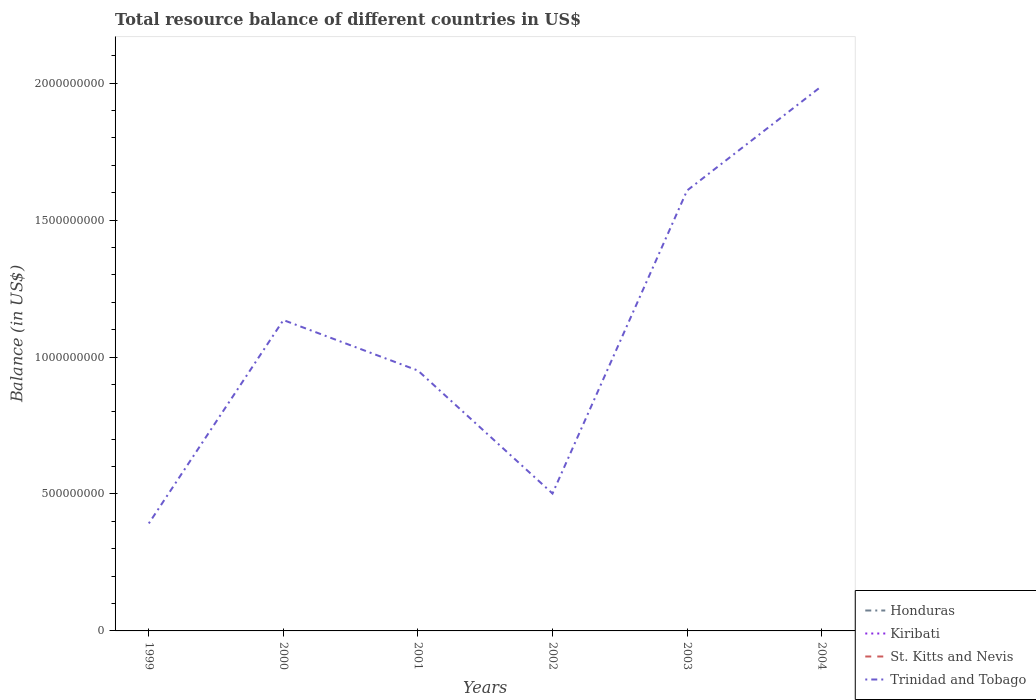How many different coloured lines are there?
Offer a terse response. 1. What is the total total resource balance in Trinidad and Tobago in the graph?
Ensure brevity in your answer.  -4.73e+08. Is the total resource balance in Kiribati strictly greater than the total resource balance in Trinidad and Tobago over the years?
Give a very brief answer. Yes. How many lines are there?
Provide a short and direct response. 1. How many years are there in the graph?
Make the answer very short. 6. How many legend labels are there?
Offer a very short reply. 4. How are the legend labels stacked?
Your answer should be very brief. Vertical. What is the title of the graph?
Provide a short and direct response. Total resource balance of different countries in US$. Does "Korea (Republic)" appear as one of the legend labels in the graph?
Offer a very short reply. No. What is the label or title of the X-axis?
Offer a very short reply. Years. What is the label or title of the Y-axis?
Your response must be concise. Balance (in US$). What is the Balance (in US$) in Honduras in 1999?
Keep it short and to the point. 0. What is the Balance (in US$) of Kiribati in 1999?
Your response must be concise. 0. What is the Balance (in US$) in Trinidad and Tobago in 1999?
Keep it short and to the point. 3.92e+08. What is the Balance (in US$) in Honduras in 2000?
Offer a terse response. 0. What is the Balance (in US$) of Kiribati in 2000?
Your response must be concise. 0. What is the Balance (in US$) of Trinidad and Tobago in 2000?
Provide a succinct answer. 1.13e+09. What is the Balance (in US$) in Honduras in 2001?
Offer a very short reply. 0. What is the Balance (in US$) of Kiribati in 2001?
Give a very brief answer. 0. What is the Balance (in US$) in Trinidad and Tobago in 2001?
Ensure brevity in your answer.  9.51e+08. What is the Balance (in US$) of Honduras in 2002?
Provide a succinct answer. 0. What is the Balance (in US$) of St. Kitts and Nevis in 2002?
Provide a short and direct response. 0. What is the Balance (in US$) in Trinidad and Tobago in 2002?
Ensure brevity in your answer.  5.02e+08. What is the Balance (in US$) of Honduras in 2003?
Make the answer very short. 0. What is the Balance (in US$) in Kiribati in 2003?
Offer a terse response. 0. What is the Balance (in US$) of Trinidad and Tobago in 2003?
Ensure brevity in your answer.  1.61e+09. What is the Balance (in US$) in Kiribati in 2004?
Provide a short and direct response. 0. What is the Balance (in US$) in St. Kitts and Nevis in 2004?
Make the answer very short. 0. What is the Balance (in US$) in Trinidad and Tobago in 2004?
Keep it short and to the point. 1.99e+09. Across all years, what is the maximum Balance (in US$) in Trinidad and Tobago?
Provide a short and direct response. 1.99e+09. Across all years, what is the minimum Balance (in US$) in Trinidad and Tobago?
Offer a very short reply. 3.92e+08. What is the total Balance (in US$) in Honduras in the graph?
Provide a short and direct response. 0. What is the total Balance (in US$) of Kiribati in the graph?
Your answer should be compact. 0. What is the total Balance (in US$) of Trinidad and Tobago in the graph?
Your answer should be very brief. 6.58e+09. What is the difference between the Balance (in US$) in Trinidad and Tobago in 1999 and that in 2000?
Your answer should be very brief. -7.43e+08. What is the difference between the Balance (in US$) of Trinidad and Tobago in 1999 and that in 2001?
Offer a terse response. -5.58e+08. What is the difference between the Balance (in US$) of Trinidad and Tobago in 1999 and that in 2002?
Make the answer very short. -1.09e+08. What is the difference between the Balance (in US$) of Trinidad and Tobago in 1999 and that in 2003?
Provide a short and direct response. -1.22e+09. What is the difference between the Balance (in US$) in Trinidad and Tobago in 1999 and that in 2004?
Offer a very short reply. -1.60e+09. What is the difference between the Balance (in US$) in Trinidad and Tobago in 2000 and that in 2001?
Offer a terse response. 1.84e+08. What is the difference between the Balance (in US$) of Trinidad and Tobago in 2000 and that in 2002?
Your answer should be very brief. 6.33e+08. What is the difference between the Balance (in US$) in Trinidad and Tobago in 2000 and that in 2003?
Give a very brief answer. -4.73e+08. What is the difference between the Balance (in US$) in Trinidad and Tobago in 2000 and that in 2004?
Ensure brevity in your answer.  -8.54e+08. What is the difference between the Balance (in US$) in Trinidad and Tobago in 2001 and that in 2002?
Provide a short and direct response. 4.49e+08. What is the difference between the Balance (in US$) in Trinidad and Tobago in 2001 and that in 2003?
Make the answer very short. -6.57e+08. What is the difference between the Balance (in US$) in Trinidad and Tobago in 2001 and that in 2004?
Your answer should be compact. -1.04e+09. What is the difference between the Balance (in US$) in Trinidad and Tobago in 2002 and that in 2003?
Your answer should be very brief. -1.11e+09. What is the difference between the Balance (in US$) of Trinidad and Tobago in 2002 and that in 2004?
Keep it short and to the point. -1.49e+09. What is the difference between the Balance (in US$) in Trinidad and Tobago in 2003 and that in 2004?
Provide a succinct answer. -3.81e+08. What is the average Balance (in US$) of Kiribati per year?
Your answer should be compact. 0. What is the average Balance (in US$) of Trinidad and Tobago per year?
Make the answer very short. 1.10e+09. What is the ratio of the Balance (in US$) of Trinidad and Tobago in 1999 to that in 2000?
Offer a terse response. 0.35. What is the ratio of the Balance (in US$) of Trinidad and Tobago in 1999 to that in 2001?
Give a very brief answer. 0.41. What is the ratio of the Balance (in US$) of Trinidad and Tobago in 1999 to that in 2002?
Provide a short and direct response. 0.78. What is the ratio of the Balance (in US$) of Trinidad and Tobago in 1999 to that in 2003?
Provide a succinct answer. 0.24. What is the ratio of the Balance (in US$) of Trinidad and Tobago in 1999 to that in 2004?
Give a very brief answer. 0.2. What is the ratio of the Balance (in US$) in Trinidad and Tobago in 2000 to that in 2001?
Provide a short and direct response. 1.19. What is the ratio of the Balance (in US$) in Trinidad and Tobago in 2000 to that in 2002?
Your answer should be compact. 2.26. What is the ratio of the Balance (in US$) in Trinidad and Tobago in 2000 to that in 2003?
Make the answer very short. 0.71. What is the ratio of the Balance (in US$) in Trinidad and Tobago in 2000 to that in 2004?
Ensure brevity in your answer.  0.57. What is the ratio of the Balance (in US$) in Trinidad and Tobago in 2001 to that in 2002?
Make the answer very short. 1.89. What is the ratio of the Balance (in US$) in Trinidad and Tobago in 2001 to that in 2003?
Provide a short and direct response. 0.59. What is the ratio of the Balance (in US$) in Trinidad and Tobago in 2001 to that in 2004?
Keep it short and to the point. 0.48. What is the ratio of the Balance (in US$) in Trinidad and Tobago in 2002 to that in 2003?
Keep it short and to the point. 0.31. What is the ratio of the Balance (in US$) of Trinidad and Tobago in 2002 to that in 2004?
Keep it short and to the point. 0.25. What is the ratio of the Balance (in US$) in Trinidad and Tobago in 2003 to that in 2004?
Give a very brief answer. 0.81. What is the difference between the highest and the second highest Balance (in US$) of Trinidad and Tobago?
Your answer should be very brief. 3.81e+08. What is the difference between the highest and the lowest Balance (in US$) in Trinidad and Tobago?
Provide a succinct answer. 1.60e+09. 